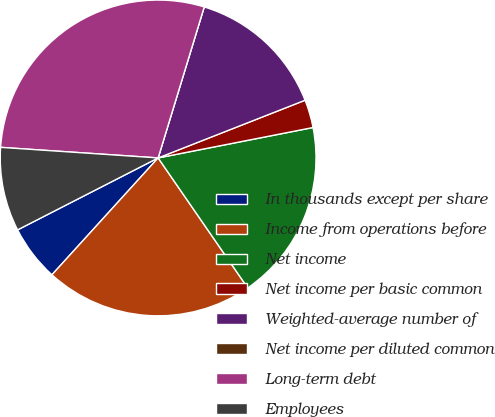Convert chart. <chart><loc_0><loc_0><loc_500><loc_500><pie_chart><fcel>In thousands except per share<fcel>Income from operations before<fcel>Net income<fcel>Net income per basic common<fcel>Weighted-average number of<fcel>Net income per diluted common<fcel>Long-term debt<fcel>Employees<nl><fcel>5.73%<fcel>21.35%<fcel>18.48%<fcel>2.87%<fcel>14.33%<fcel>0.0%<fcel>28.65%<fcel>8.6%<nl></chart> 